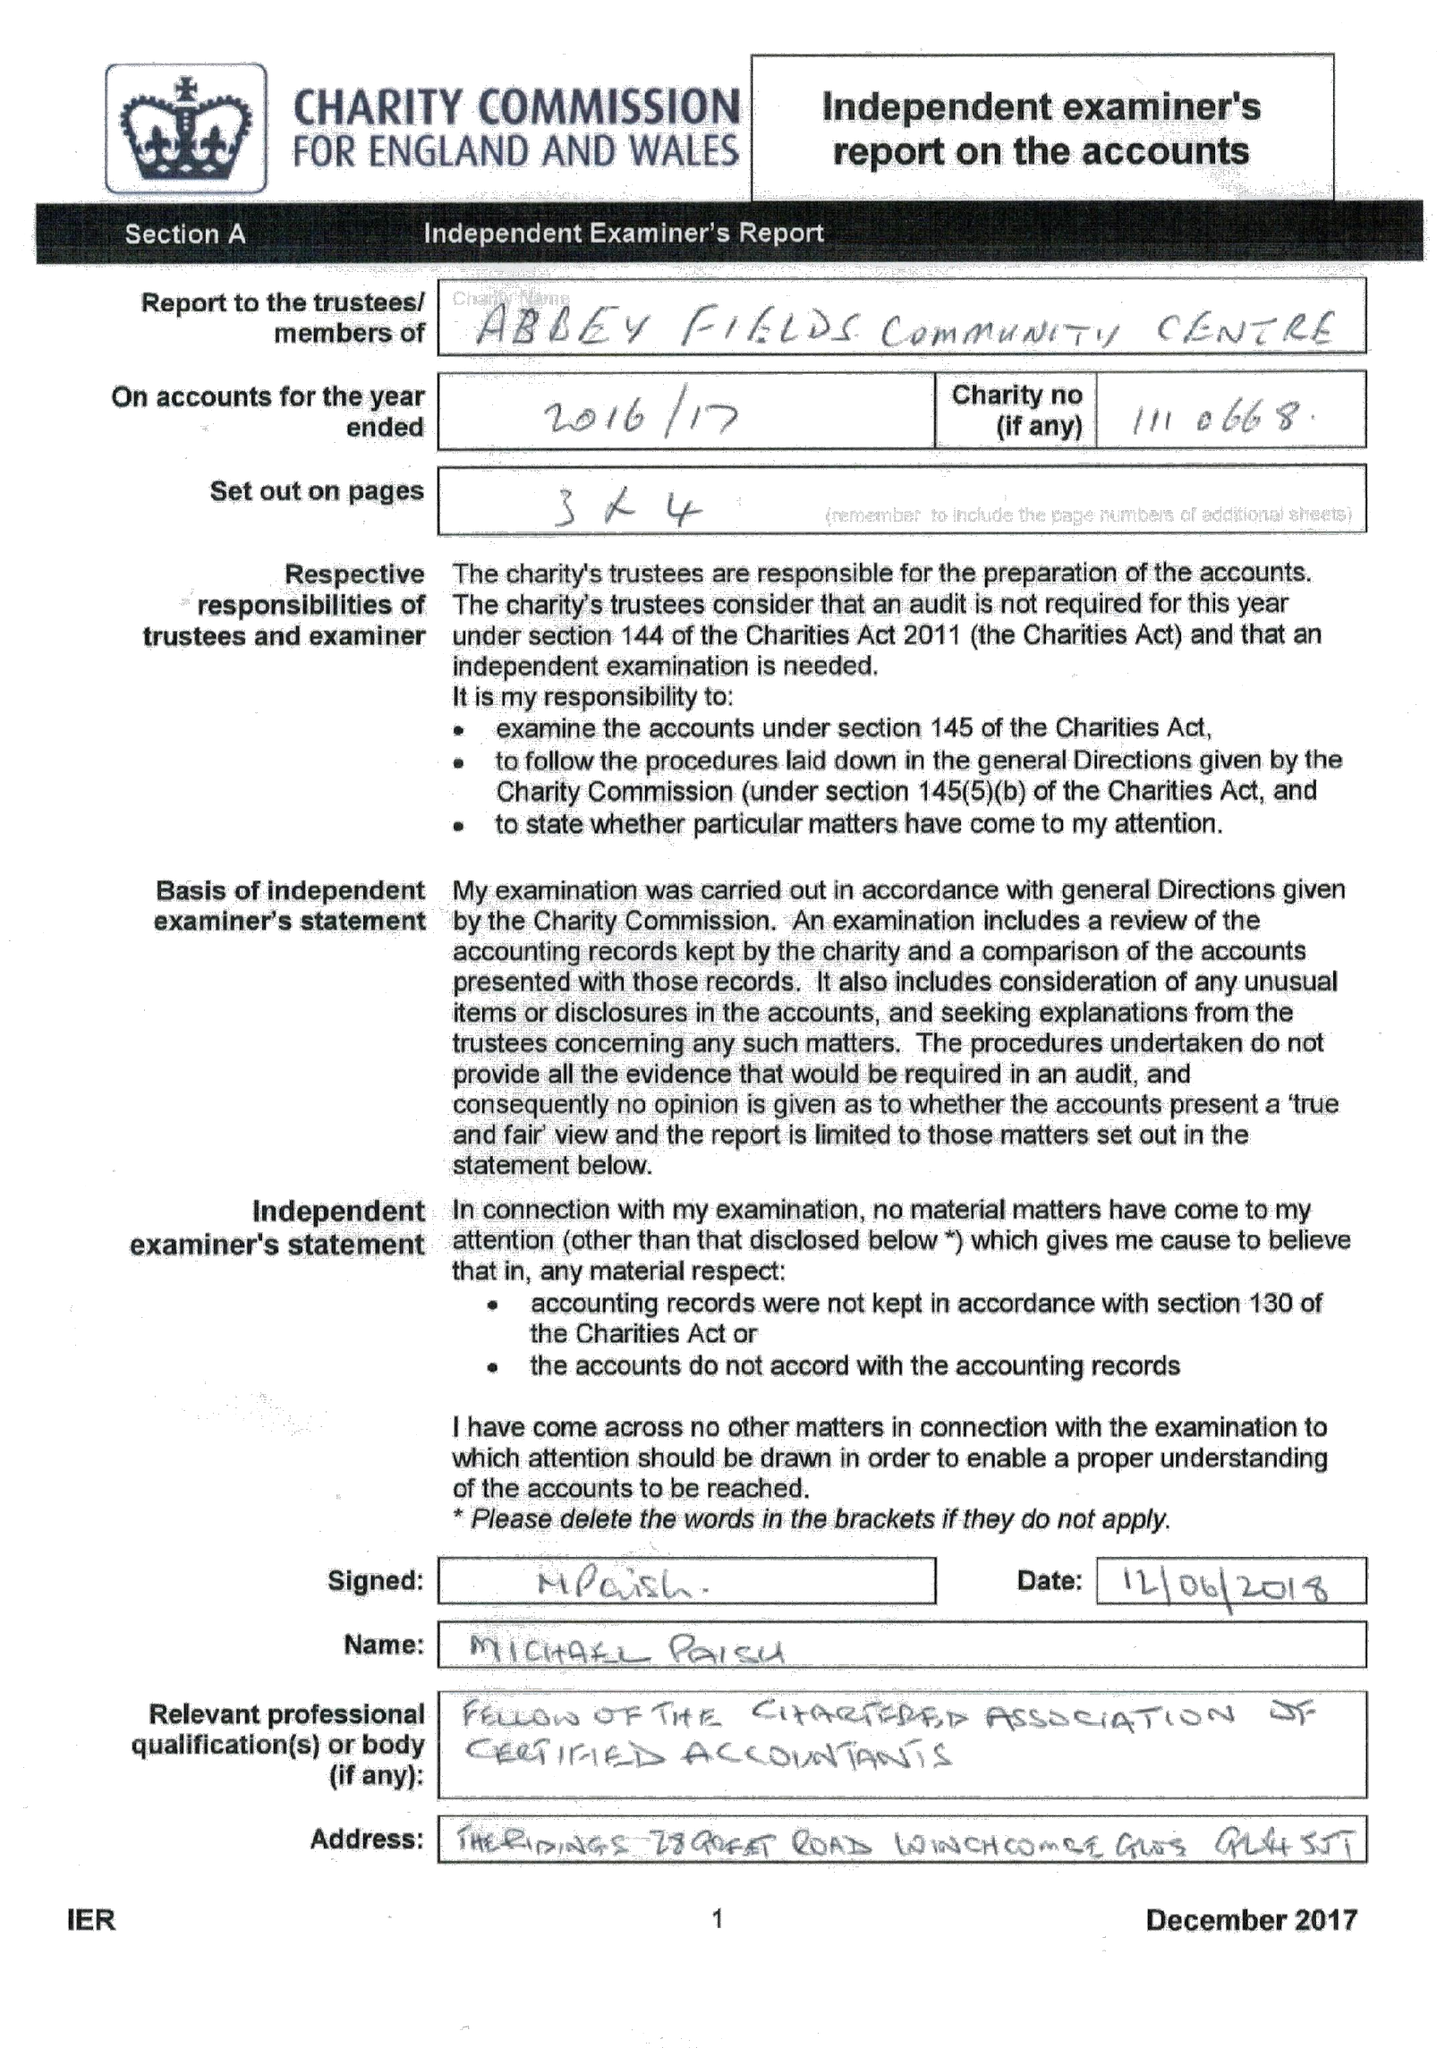What is the value for the address__street_line?
Answer the question using a single word or phrase. BACK LANE 